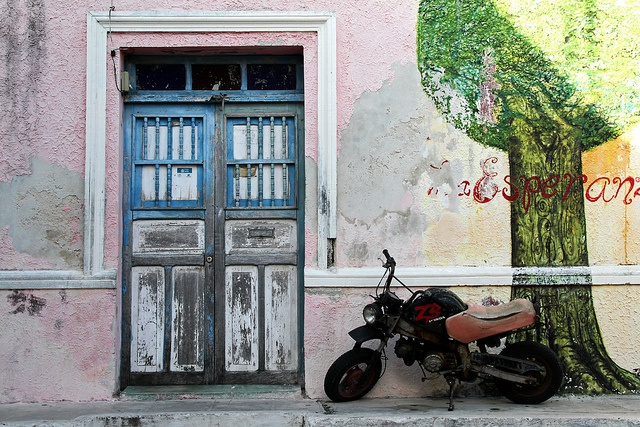Describe the objects in this image and their specific colors. I can see a motorcycle in darkgray, black, gray, and maroon tones in this image. 